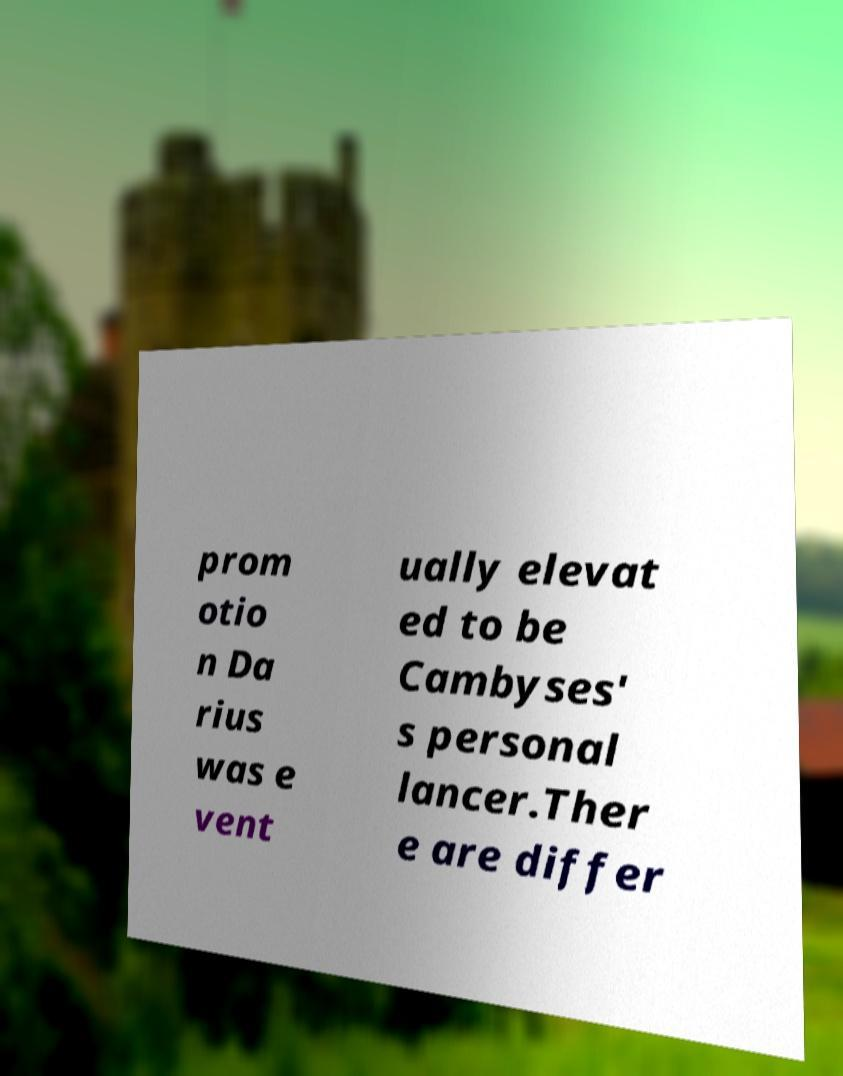Please identify and transcribe the text found in this image. prom otio n Da rius was e vent ually elevat ed to be Cambyses' s personal lancer.Ther e are differ 